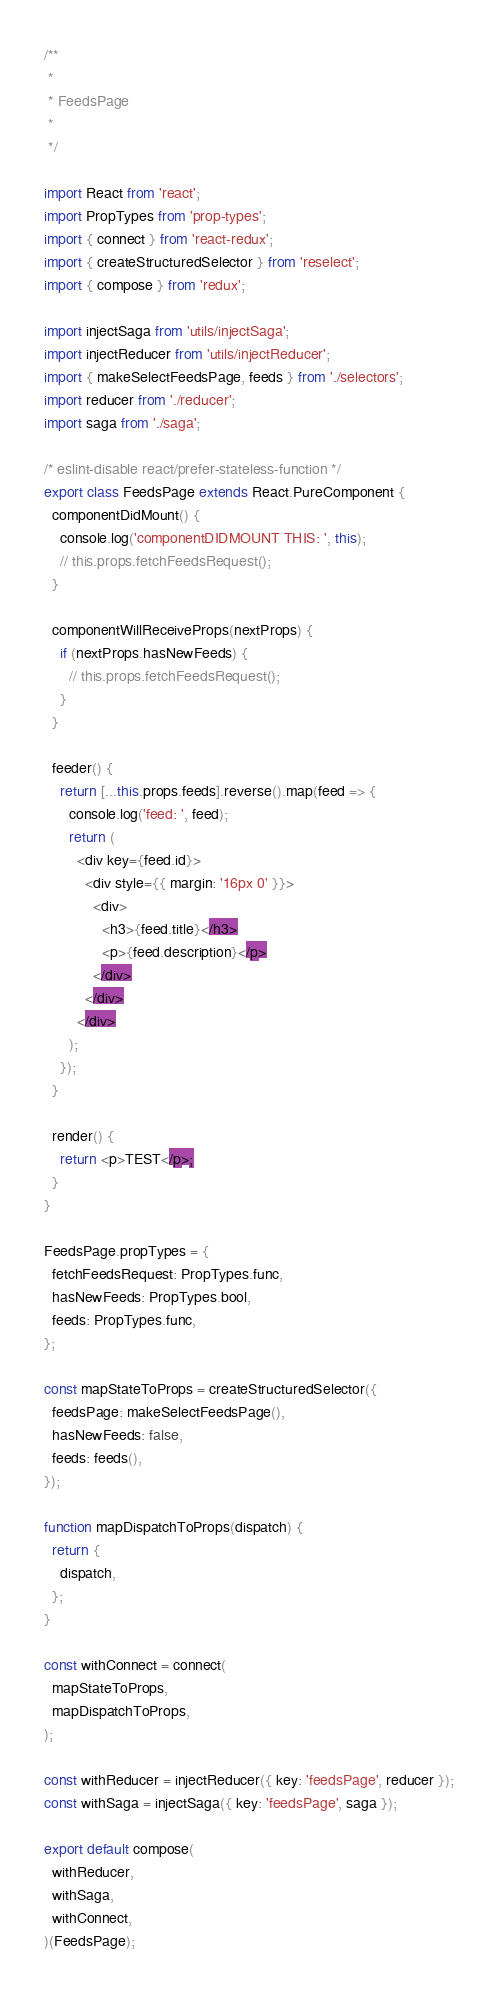Convert code to text. <code><loc_0><loc_0><loc_500><loc_500><_JavaScript_>/**
 *
 * FeedsPage
 *
 */

import React from 'react';
import PropTypes from 'prop-types';
import { connect } from 'react-redux';
import { createStructuredSelector } from 'reselect';
import { compose } from 'redux';

import injectSaga from 'utils/injectSaga';
import injectReducer from 'utils/injectReducer';
import { makeSelectFeedsPage, feeds } from './selectors';
import reducer from './reducer';
import saga from './saga';

/* eslint-disable react/prefer-stateless-function */
export class FeedsPage extends React.PureComponent {
  componentDidMount() {
    console.log('componentDIDMOUNT THIS: ', this);
    // this.props.fetchFeedsRequest();
  }

  componentWillReceiveProps(nextProps) {
    if (nextProps.hasNewFeeds) {
      // this.props.fetchFeedsRequest();
    }
  }

  feeder() {
    return [...this.props.feeds].reverse().map(feed => {
      console.log('feed: ', feed);
      return (
        <div key={feed.id}>
          <div style={{ margin: '16px 0' }}>
            <div>
              <h3>{feed.title}</h3>
              <p>{feed.description}</p>
            </div>
          </div>
        </div>
      );
    });
  }

  render() {
    return <p>TEST</p>;
  }
}

FeedsPage.propTypes = {
  fetchFeedsRequest: PropTypes.func,
  hasNewFeeds: PropTypes.bool,
  feeds: PropTypes.func,
};

const mapStateToProps = createStructuredSelector({
  feedsPage: makeSelectFeedsPage(),
  hasNewFeeds: false,
  feeds: feeds(),
});

function mapDispatchToProps(dispatch) {
  return {
    dispatch,
  };
}

const withConnect = connect(
  mapStateToProps,
  mapDispatchToProps,
);

const withReducer = injectReducer({ key: 'feedsPage', reducer });
const withSaga = injectSaga({ key: 'feedsPage', saga });

export default compose(
  withReducer,
  withSaga,
  withConnect,
)(FeedsPage);
</code> 